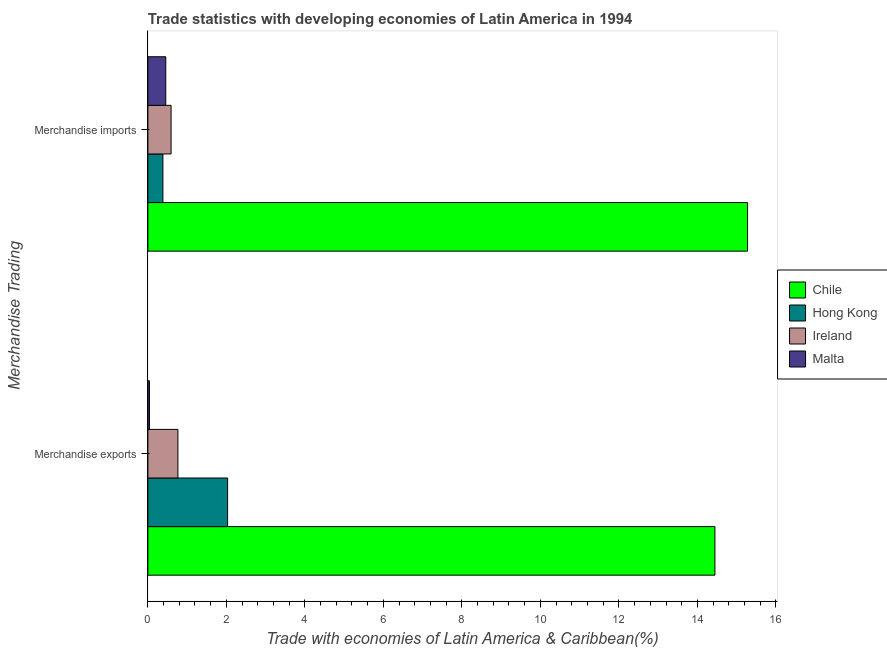Are the number of bars on each tick of the Y-axis equal?
Provide a short and direct response. Yes. How many bars are there on the 2nd tick from the bottom?
Provide a succinct answer. 4. What is the label of the 2nd group of bars from the top?
Your response must be concise. Merchandise exports. What is the merchandise exports in Chile?
Give a very brief answer. 14.45. Across all countries, what is the maximum merchandise imports?
Your answer should be compact. 15.28. Across all countries, what is the minimum merchandise exports?
Make the answer very short. 0.04. In which country was the merchandise imports maximum?
Provide a short and direct response. Chile. In which country was the merchandise exports minimum?
Your answer should be very brief. Malta. What is the total merchandise exports in the graph?
Make the answer very short. 17.28. What is the difference between the merchandise imports in Ireland and that in Chile?
Provide a succinct answer. -14.69. What is the difference between the merchandise exports in Chile and the merchandise imports in Ireland?
Provide a succinct answer. 13.86. What is the average merchandise exports per country?
Your response must be concise. 4.32. What is the difference between the merchandise exports and merchandise imports in Ireland?
Your answer should be compact. 0.17. In how many countries, is the merchandise imports greater than 6 %?
Your answer should be compact. 1. What is the ratio of the merchandise exports in Chile to that in Hong Kong?
Provide a short and direct response. 7.11. What does the 1st bar from the bottom in Merchandise exports represents?
Offer a terse response. Chile. Are all the bars in the graph horizontal?
Your answer should be compact. Yes. What is the difference between two consecutive major ticks on the X-axis?
Provide a short and direct response. 2. Are the values on the major ticks of X-axis written in scientific E-notation?
Provide a succinct answer. No. Where does the legend appear in the graph?
Offer a terse response. Center right. How many legend labels are there?
Ensure brevity in your answer.  4. How are the legend labels stacked?
Offer a terse response. Vertical. What is the title of the graph?
Provide a succinct answer. Trade statistics with developing economies of Latin America in 1994. What is the label or title of the X-axis?
Provide a succinct answer. Trade with economies of Latin America & Caribbean(%). What is the label or title of the Y-axis?
Provide a succinct answer. Merchandise Trading. What is the Trade with economies of Latin America & Caribbean(%) in Chile in Merchandise exports?
Provide a succinct answer. 14.45. What is the Trade with economies of Latin America & Caribbean(%) of Hong Kong in Merchandise exports?
Your answer should be compact. 2.03. What is the Trade with economies of Latin America & Caribbean(%) in Ireland in Merchandise exports?
Ensure brevity in your answer.  0.77. What is the Trade with economies of Latin America & Caribbean(%) in Malta in Merchandise exports?
Offer a terse response. 0.04. What is the Trade with economies of Latin America & Caribbean(%) of Chile in Merchandise imports?
Your answer should be compact. 15.28. What is the Trade with economies of Latin America & Caribbean(%) of Hong Kong in Merchandise imports?
Offer a very short reply. 0.38. What is the Trade with economies of Latin America & Caribbean(%) in Ireland in Merchandise imports?
Your answer should be compact. 0.59. What is the Trade with economies of Latin America & Caribbean(%) of Malta in Merchandise imports?
Your answer should be very brief. 0.46. Across all Merchandise Trading, what is the maximum Trade with economies of Latin America & Caribbean(%) of Chile?
Your answer should be very brief. 15.28. Across all Merchandise Trading, what is the maximum Trade with economies of Latin America & Caribbean(%) of Hong Kong?
Make the answer very short. 2.03. Across all Merchandise Trading, what is the maximum Trade with economies of Latin America & Caribbean(%) of Ireland?
Offer a terse response. 0.77. Across all Merchandise Trading, what is the maximum Trade with economies of Latin America & Caribbean(%) in Malta?
Ensure brevity in your answer.  0.46. Across all Merchandise Trading, what is the minimum Trade with economies of Latin America & Caribbean(%) of Chile?
Give a very brief answer. 14.45. Across all Merchandise Trading, what is the minimum Trade with economies of Latin America & Caribbean(%) in Hong Kong?
Your response must be concise. 0.38. Across all Merchandise Trading, what is the minimum Trade with economies of Latin America & Caribbean(%) in Ireland?
Your answer should be compact. 0.59. Across all Merchandise Trading, what is the minimum Trade with economies of Latin America & Caribbean(%) of Malta?
Keep it short and to the point. 0.04. What is the total Trade with economies of Latin America & Caribbean(%) in Chile in the graph?
Your answer should be very brief. 29.72. What is the total Trade with economies of Latin America & Caribbean(%) in Hong Kong in the graph?
Offer a terse response. 2.41. What is the total Trade with economies of Latin America & Caribbean(%) in Ireland in the graph?
Give a very brief answer. 1.36. What is the total Trade with economies of Latin America & Caribbean(%) of Malta in the graph?
Make the answer very short. 0.5. What is the difference between the Trade with economies of Latin America & Caribbean(%) in Chile in Merchandise exports and that in Merchandise imports?
Offer a terse response. -0.83. What is the difference between the Trade with economies of Latin America & Caribbean(%) of Hong Kong in Merchandise exports and that in Merchandise imports?
Offer a very short reply. 1.65. What is the difference between the Trade with economies of Latin America & Caribbean(%) in Ireland in Merchandise exports and that in Merchandise imports?
Give a very brief answer. 0.17. What is the difference between the Trade with economies of Latin America & Caribbean(%) in Malta in Merchandise exports and that in Merchandise imports?
Offer a very short reply. -0.42. What is the difference between the Trade with economies of Latin America & Caribbean(%) in Chile in Merchandise exports and the Trade with economies of Latin America & Caribbean(%) in Hong Kong in Merchandise imports?
Give a very brief answer. 14.06. What is the difference between the Trade with economies of Latin America & Caribbean(%) of Chile in Merchandise exports and the Trade with economies of Latin America & Caribbean(%) of Ireland in Merchandise imports?
Your answer should be compact. 13.86. What is the difference between the Trade with economies of Latin America & Caribbean(%) of Chile in Merchandise exports and the Trade with economies of Latin America & Caribbean(%) of Malta in Merchandise imports?
Provide a short and direct response. 13.99. What is the difference between the Trade with economies of Latin America & Caribbean(%) in Hong Kong in Merchandise exports and the Trade with economies of Latin America & Caribbean(%) in Ireland in Merchandise imports?
Make the answer very short. 1.44. What is the difference between the Trade with economies of Latin America & Caribbean(%) of Hong Kong in Merchandise exports and the Trade with economies of Latin America & Caribbean(%) of Malta in Merchandise imports?
Keep it short and to the point. 1.58. What is the difference between the Trade with economies of Latin America & Caribbean(%) of Ireland in Merchandise exports and the Trade with economies of Latin America & Caribbean(%) of Malta in Merchandise imports?
Offer a very short reply. 0.31. What is the average Trade with economies of Latin America & Caribbean(%) in Chile per Merchandise Trading?
Your answer should be compact. 14.86. What is the average Trade with economies of Latin America & Caribbean(%) in Hong Kong per Merchandise Trading?
Keep it short and to the point. 1.21. What is the average Trade with economies of Latin America & Caribbean(%) in Ireland per Merchandise Trading?
Your response must be concise. 0.68. What is the average Trade with economies of Latin America & Caribbean(%) of Malta per Merchandise Trading?
Make the answer very short. 0.25. What is the difference between the Trade with economies of Latin America & Caribbean(%) in Chile and Trade with economies of Latin America & Caribbean(%) in Hong Kong in Merchandise exports?
Make the answer very short. 12.41. What is the difference between the Trade with economies of Latin America & Caribbean(%) of Chile and Trade with economies of Latin America & Caribbean(%) of Ireland in Merchandise exports?
Provide a short and direct response. 13.68. What is the difference between the Trade with economies of Latin America & Caribbean(%) in Chile and Trade with economies of Latin America & Caribbean(%) in Malta in Merchandise exports?
Offer a very short reply. 14.41. What is the difference between the Trade with economies of Latin America & Caribbean(%) of Hong Kong and Trade with economies of Latin America & Caribbean(%) of Ireland in Merchandise exports?
Provide a short and direct response. 1.27. What is the difference between the Trade with economies of Latin America & Caribbean(%) of Hong Kong and Trade with economies of Latin America & Caribbean(%) of Malta in Merchandise exports?
Your answer should be very brief. 1.99. What is the difference between the Trade with economies of Latin America & Caribbean(%) of Ireland and Trade with economies of Latin America & Caribbean(%) of Malta in Merchandise exports?
Your response must be concise. 0.72. What is the difference between the Trade with economies of Latin America & Caribbean(%) in Chile and Trade with economies of Latin America & Caribbean(%) in Hong Kong in Merchandise imports?
Provide a succinct answer. 14.89. What is the difference between the Trade with economies of Latin America & Caribbean(%) in Chile and Trade with economies of Latin America & Caribbean(%) in Ireland in Merchandise imports?
Provide a succinct answer. 14.69. What is the difference between the Trade with economies of Latin America & Caribbean(%) of Chile and Trade with economies of Latin America & Caribbean(%) of Malta in Merchandise imports?
Provide a succinct answer. 14.82. What is the difference between the Trade with economies of Latin America & Caribbean(%) of Hong Kong and Trade with economies of Latin America & Caribbean(%) of Ireland in Merchandise imports?
Your response must be concise. -0.21. What is the difference between the Trade with economies of Latin America & Caribbean(%) of Hong Kong and Trade with economies of Latin America & Caribbean(%) of Malta in Merchandise imports?
Offer a terse response. -0.07. What is the difference between the Trade with economies of Latin America & Caribbean(%) of Ireland and Trade with economies of Latin America & Caribbean(%) of Malta in Merchandise imports?
Make the answer very short. 0.14. What is the ratio of the Trade with economies of Latin America & Caribbean(%) in Chile in Merchandise exports to that in Merchandise imports?
Keep it short and to the point. 0.95. What is the ratio of the Trade with economies of Latin America & Caribbean(%) of Hong Kong in Merchandise exports to that in Merchandise imports?
Provide a short and direct response. 5.3. What is the ratio of the Trade with economies of Latin America & Caribbean(%) of Ireland in Merchandise exports to that in Merchandise imports?
Your answer should be very brief. 1.29. What is the ratio of the Trade with economies of Latin America & Caribbean(%) of Malta in Merchandise exports to that in Merchandise imports?
Give a very brief answer. 0.09. What is the difference between the highest and the second highest Trade with economies of Latin America & Caribbean(%) in Chile?
Provide a succinct answer. 0.83. What is the difference between the highest and the second highest Trade with economies of Latin America & Caribbean(%) in Hong Kong?
Keep it short and to the point. 1.65. What is the difference between the highest and the second highest Trade with economies of Latin America & Caribbean(%) in Ireland?
Offer a very short reply. 0.17. What is the difference between the highest and the second highest Trade with economies of Latin America & Caribbean(%) of Malta?
Provide a short and direct response. 0.42. What is the difference between the highest and the lowest Trade with economies of Latin America & Caribbean(%) of Chile?
Offer a very short reply. 0.83. What is the difference between the highest and the lowest Trade with economies of Latin America & Caribbean(%) of Hong Kong?
Make the answer very short. 1.65. What is the difference between the highest and the lowest Trade with economies of Latin America & Caribbean(%) of Ireland?
Ensure brevity in your answer.  0.17. What is the difference between the highest and the lowest Trade with economies of Latin America & Caribbean(%) of Malta?
Your answer should be compact. 0.42. 